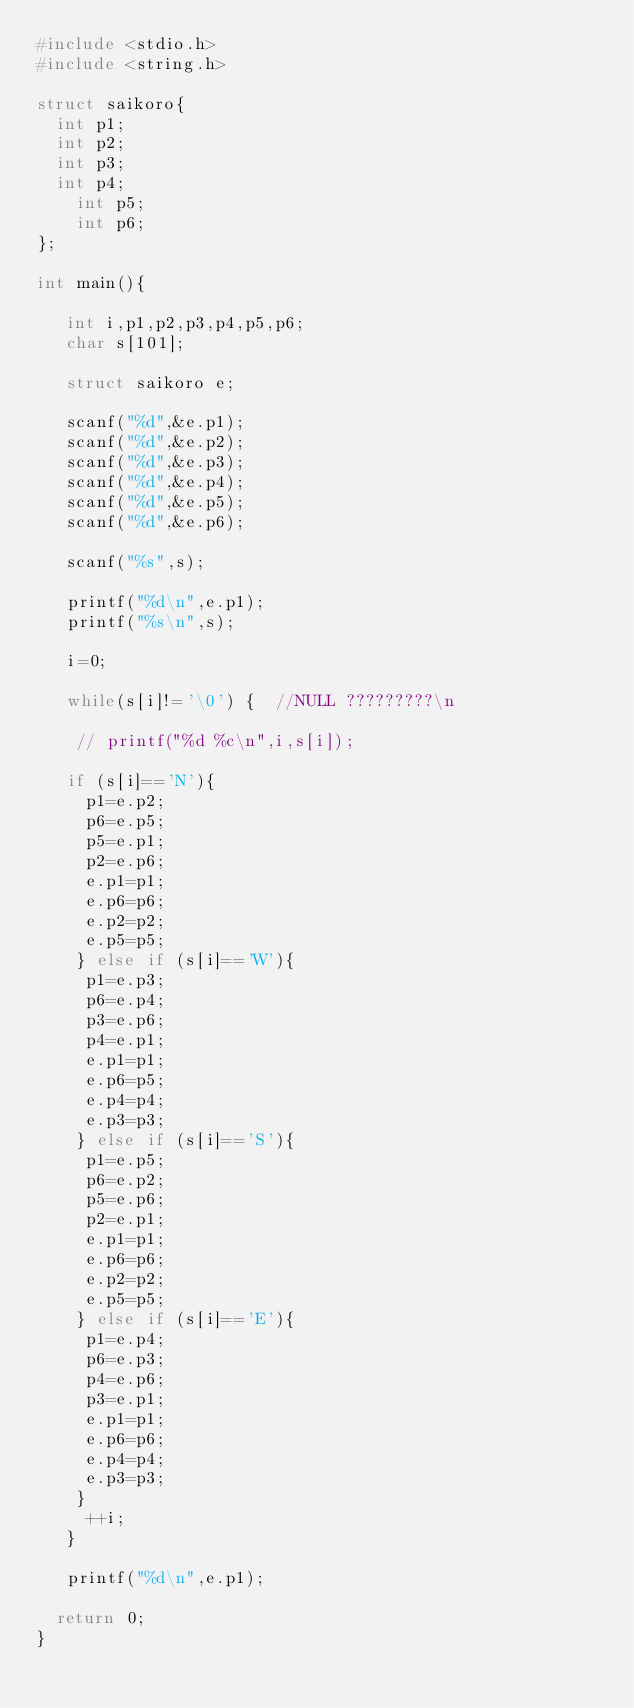Convert code to text. <code><loc_0><loc_0><loc_500><loc_500><_C_>#include <stdio.h>
#include <string.h>

struct saikoro{
	int p1;
	int p2;
	int p3;
	int p4;
    int p5;
    int p6;
};

int main(){

   int i,p1,p2,p3,p4,p5,p6;
   char s[101];
    
   struct saikoro e;
 
   scanf("%d",&e.p1);
   scanf("%d",&e.p2);
   scanf("%d",&e.p3);    	     
   scanf("%d",&e.p4);    	     
   scanf("%d",&e.p5);    	     
   scanf("%d",&e.p6);    	     
   
   scanf("%s",s);    	     
    
   printf("%d\n",e.p1);
   printf("%s\n",s);
   
   i=0;
   
   while(s[i]!='\0') {  //NULL ?????????\n
   
    // printf("%d %c\n",i,s[i]);
      
   if (s[i]=='N'){
     p1=e.p2;
     p6=e.p5;
     p5=e.p1;
     p2=e.p6;
     e.p1=p1;
     e.p6=p6;
     e.p2=p2;
     e.p5=p5;
    } else if (s[i]=='W'){
     p1=e.p3;
     p6=e.p4;
     p3=e.p6;
     p4=e.p1;
     e.p1=p1;
     e.p6=p5;
     e.p4=p4;
     e.p3=p3;
    } else if (s[i]=='S'){
     p1=e.p5;
     p6=e.p2;
     p5=e.p6;
     p2=e.p1;
     e.p1=p1;
     e.p6=p6;
     e.p2=p2;
     e.p5=p5;
    } else if (s[i]=='E'){     
     p1=e.p4;
     p6=e.p3;
     p4=e.p6;
     p3=e.p1;
     e.p1=p1;
     e.p6=p6;
     e.p4=p4;
     e.p3=p3;
    }
     ++i;
   }
 
   printf("%d\n",e.p1);

	return 0;
}</code> 